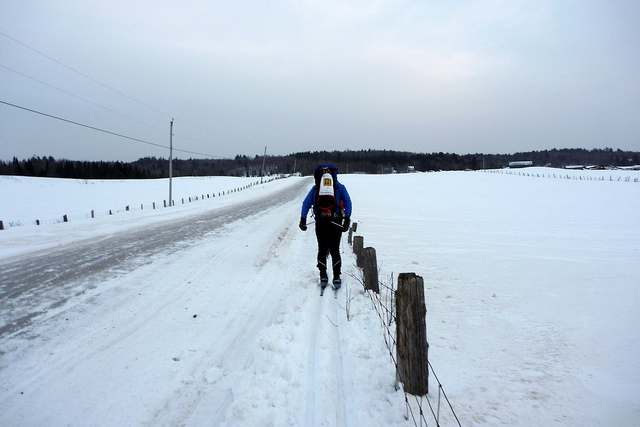Extract all visible text content from this image. 2 2 1 